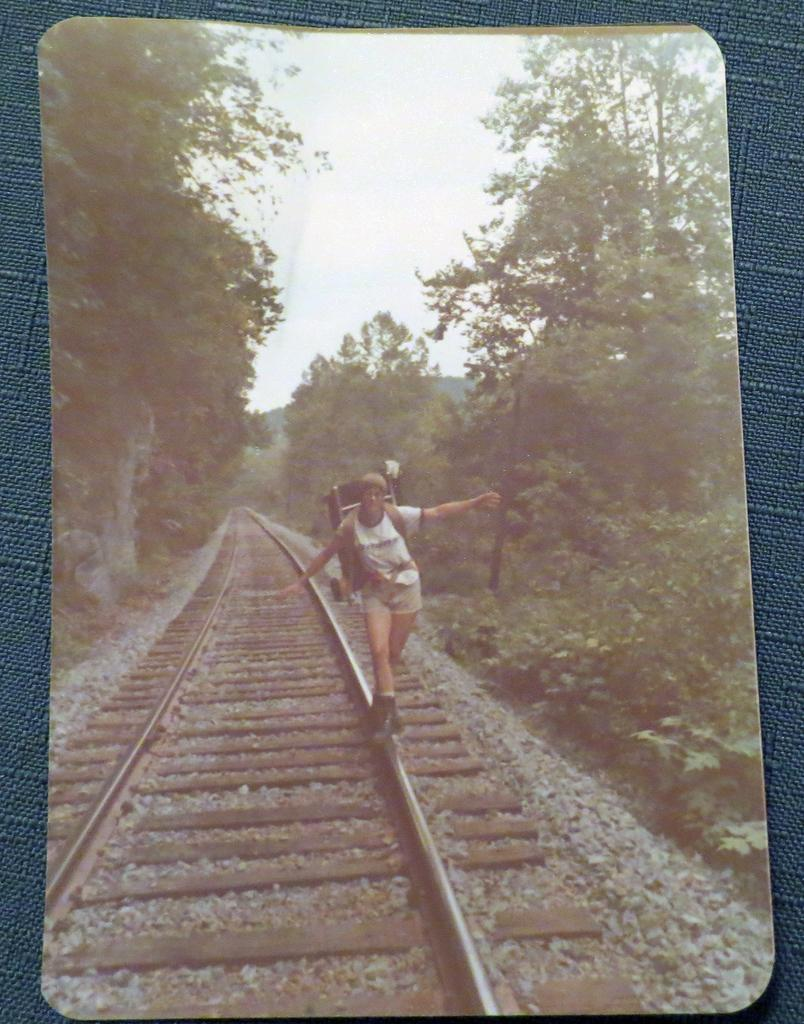What is the main subject of the image? There is a photograph of a person in the image. What is the person doing in the image? The person is standing on a railway track. What can be seen on both sides of the railway track? There are trees on either side of the railway track. What is visible at the top of the image? The sky is visible at the top of the image. What statement does the person in the image make about their favorite color? There is no statement made by the person in the image about their favorite color, as the image only shows a photograph of the person standing on a railway track. 